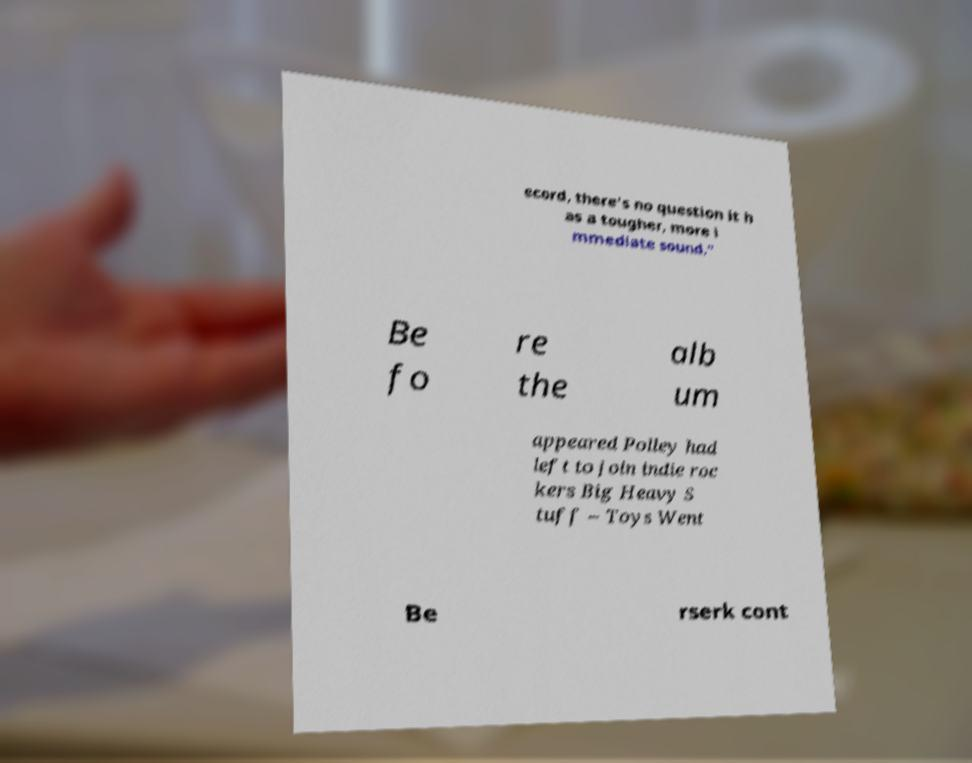I need the written content from this picture converted into text. Can you do that? ecord, there's no question it h as a tougher, more i mmediate sound." Be fo re the alb um appeared Polley had left to join indie roc kers Big Heavy S tuff – Toys Went Be rserk cont 